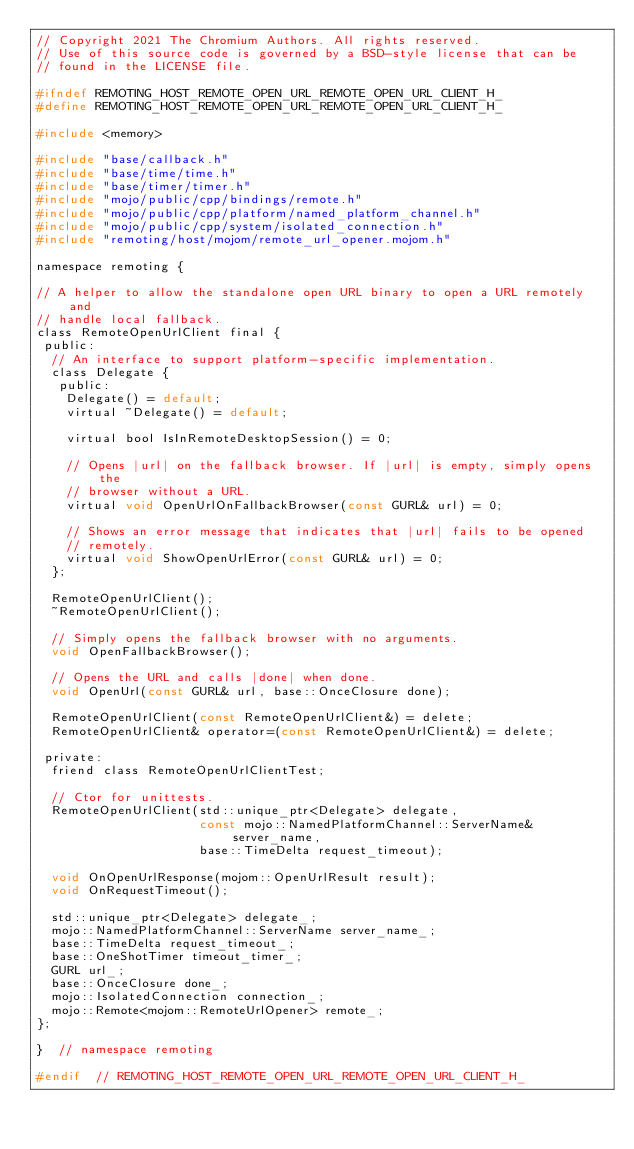<code> <loc_0><loc_0><loc_500><loc_500><_C_>// Copyright 2021 The Chromium Authors. All rights reserved.
// Use of this source code is governed by a BSD-style license that can be
// found in the LICENSE file.

#ifndef REMOTING_HOST_REMOTE_OPEN_URL_REMOTE_OPEN_URL_CLIENT_H_
#define REMOTING_HOST_REMOTE_OPEN_URL_REMOTE_OPEN_URL_CLIENT_H_

#include <memory>

#include "base/callback.h"
#include "base/time/time.h"
#include "base/timer/timer.h"
#include "mojo/public/cpp/bindings/remote.h"
#include "mojo/public/cpp/platform/named_platform_channel.h"
#include "mojo/public/cpp/system/isolated_connection.h"
#include "remoting/host/mojom/remote_url_opener.mojom.h"

namespace remoting {

// A helper to allow the standalone open URL binary to open a URL remotely and
// handle local fallback.
class RemoteOpenUrlClient final {
 public:
  // An interface to support platform-specific implementation.
  class Delegate {
   public:
    Delegate() = default;
    virtual ~Delegate() = default;

    virtual bool IsInRemoteDesktopSession() = 0;

    // Opens |url| on the fallback browser. If |url| is empty, simply opens the
    // browser without a URL.
    virtual void OpenUrlOnFallbackBrowser(const GURL& url) = 0;

    // Shows an error message that indicates that |url| fails to be opened
    // remotely.
    virtual void ShowOpenUrlError(const GURL& url) = 0;
  };

  RemoteOpenUrlClient();
  ~RemoteOpenUrlClient();

  // Simply opens the fallback browser with no arguments.
  void OpenFallbackBrowser();

  // Opens the URL and calls |done| when done.
  void OpenUrl(const GURL& url, base::OnceClosure done);

  RemoteOpenUrlClient(const RemoteOpenUrlClient&) = delete;
  RemoteOpenUrlClient& operator=(const RemoteOpenUrlClient&) = delete;

 private:
  friend class RemoteOpenUrlClientTest;

  // Ctor for unittests.
  RemoteOpenUrlClient(std::unique_ptr<Delegate> delegate,
                      const mojo::NamedPlatformChannel::ServerName& server_name,
                      base::TimeDelta request_timeout);

  void OnOpenUrlResponse(mojom::OpenUrlResult result);
  void OnRequestTimeout();

  std::unique_ptr<Delegate> delegate_;
  mojo::NamedPlatformChannel::ServerName server_name_;
  base::TimeDelta request_timeout_;
  base::OneShotTimer timeout_timer_;
  GURL url_;
  base::OnceClosure done_;
  mojo::IsolatedConnection connection_;
  mojo::Remote<mojom::RemoteUrlOpener> remote_;
};

}  // namespace remoting

#endif  // REMOTING_HOST_REMOTE_OPEN_URL_REMOTE_OPEN_URL_CLIENT_H_
</code> 